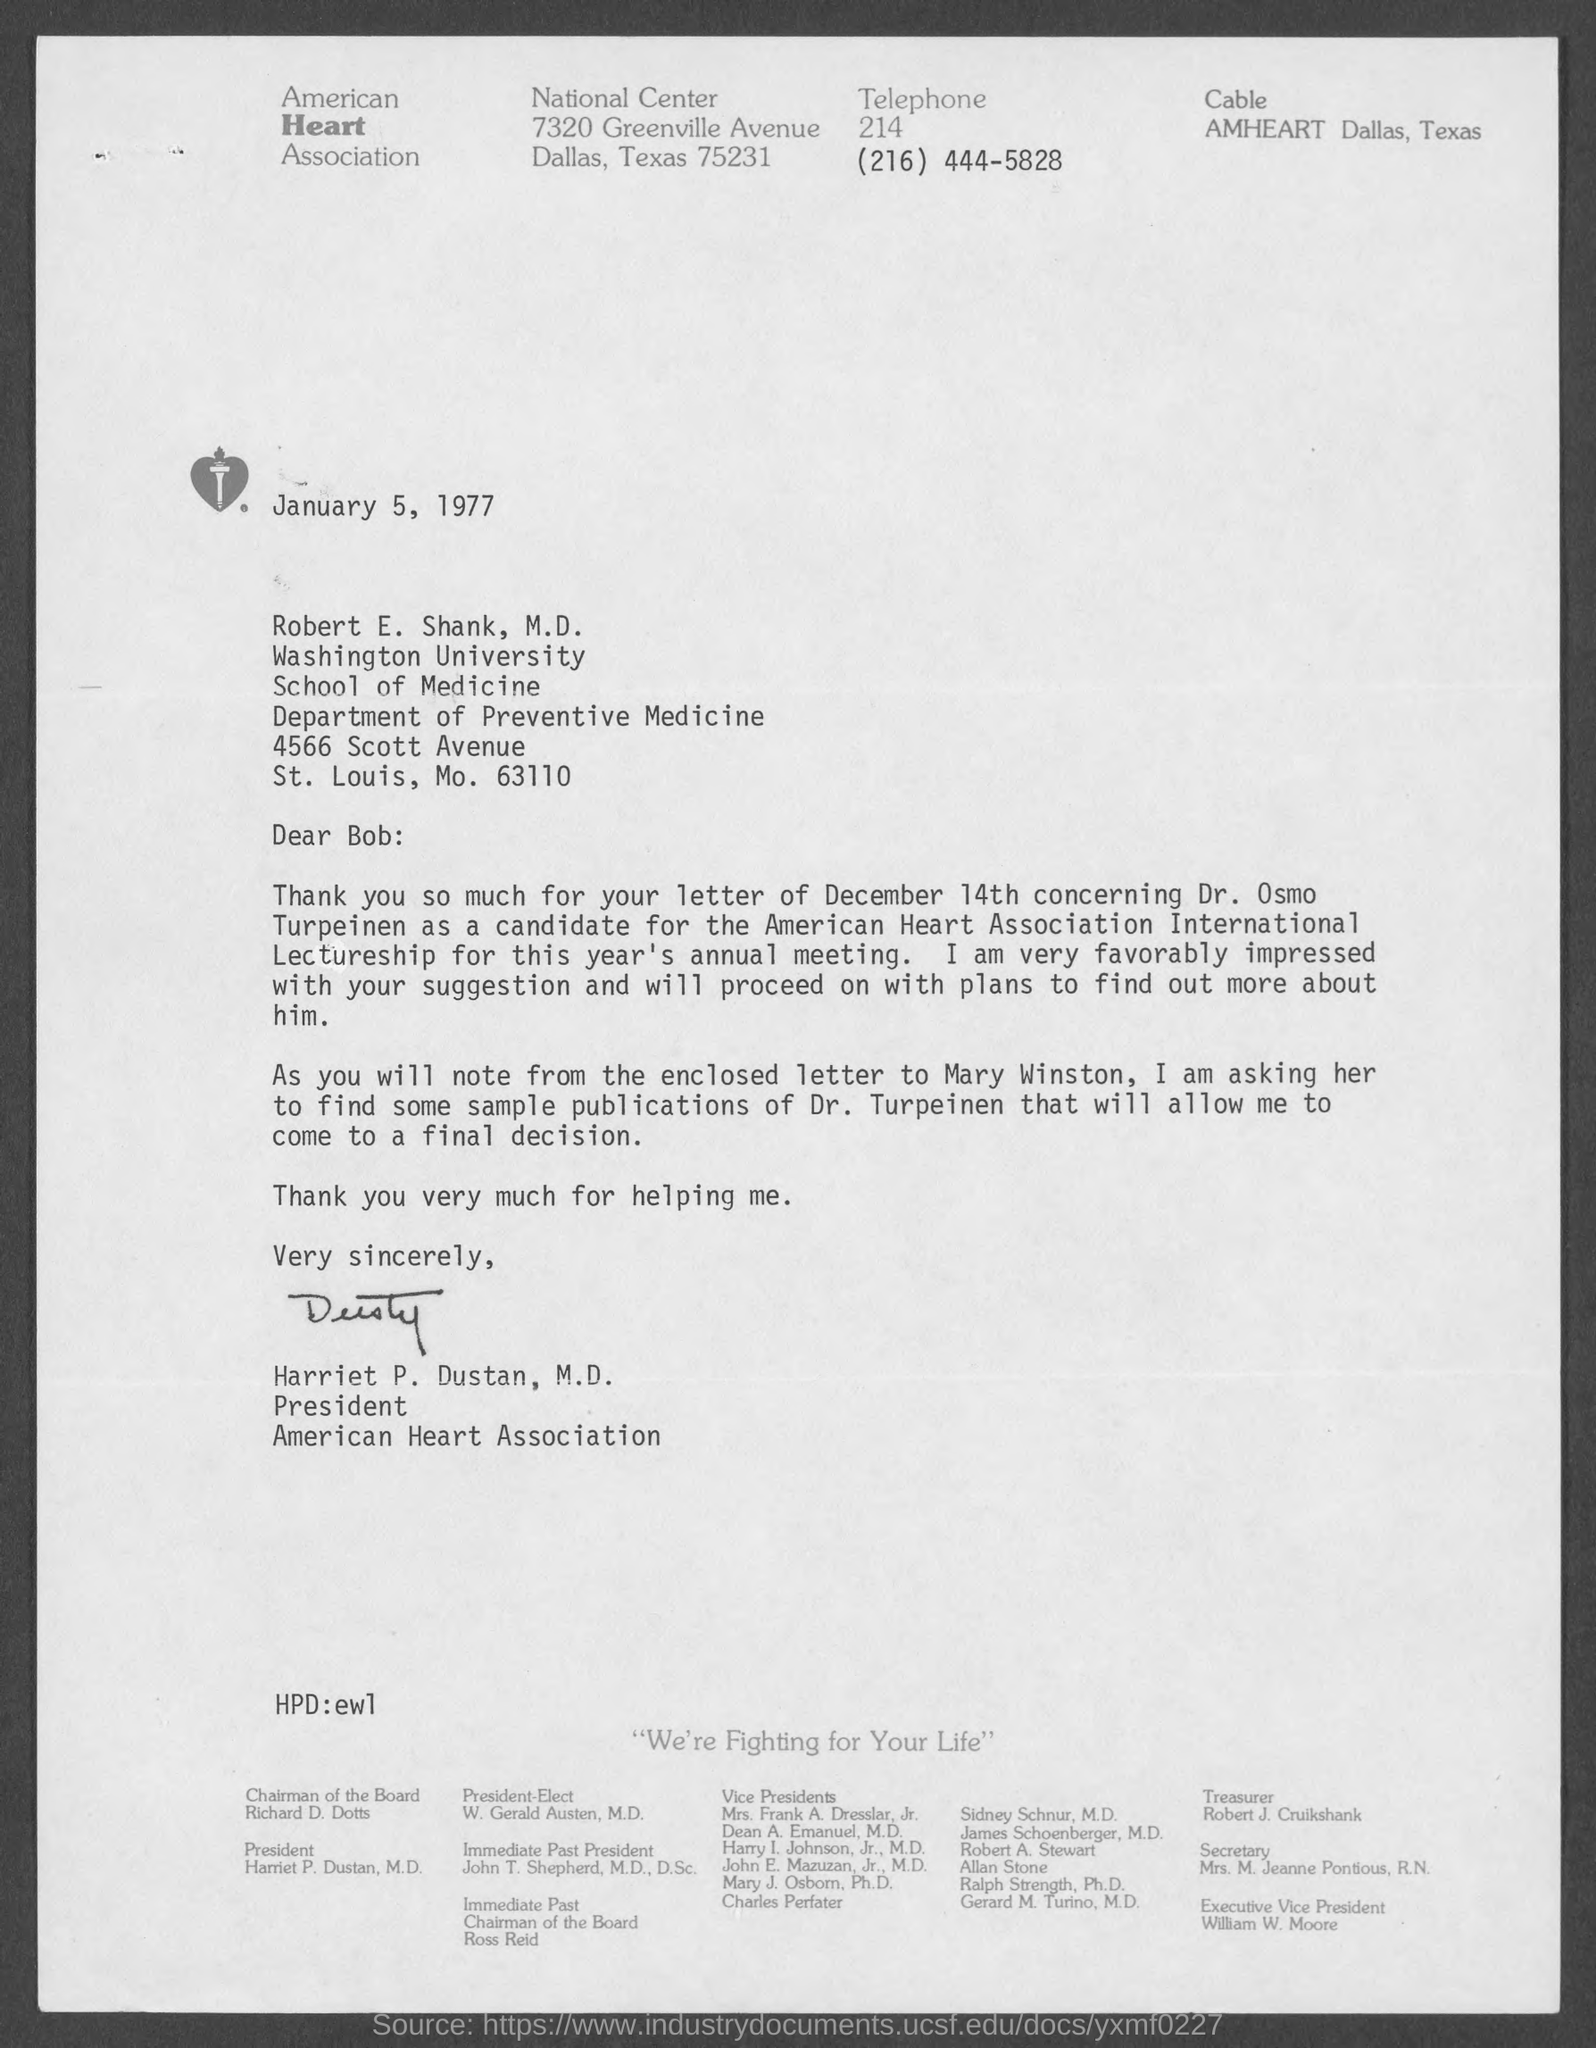Specify some key components in this picture. The letter is addressed to Robert E. Shank, M.D. The letter sent on December 14th was about Dr. Osmo Turpeinen. The date on the document is January 5, 1977. 